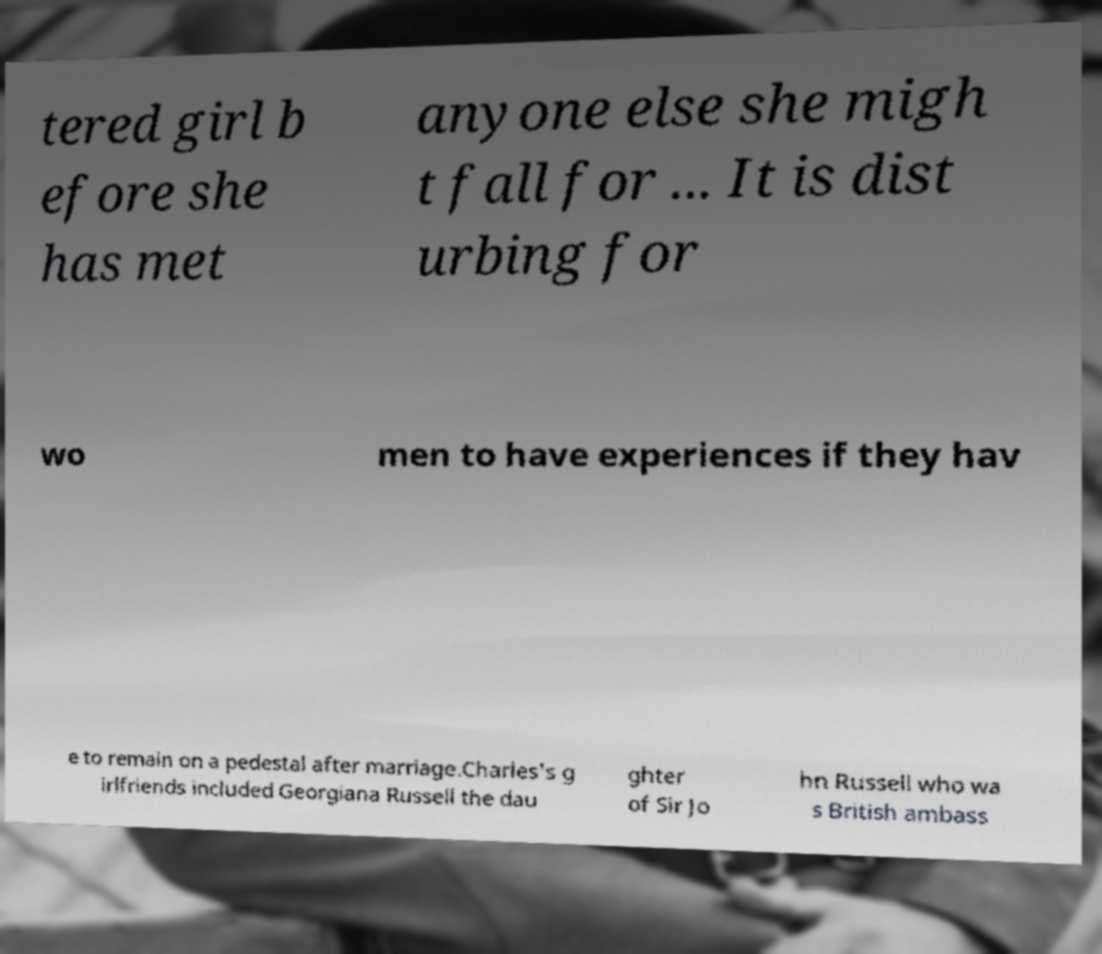What messages or text are displayed in this image? I need them in a readable, typed format. tered girl b efore she has met anyone else she migh t fall for ... It is dist urbing for wo men to have experiences if they hav e to remain on a pedestal after marriage.Charles's g irlfriends included Georgiana Russell the dau ghter of Sir Jo hn Russell who wa s British ambass 